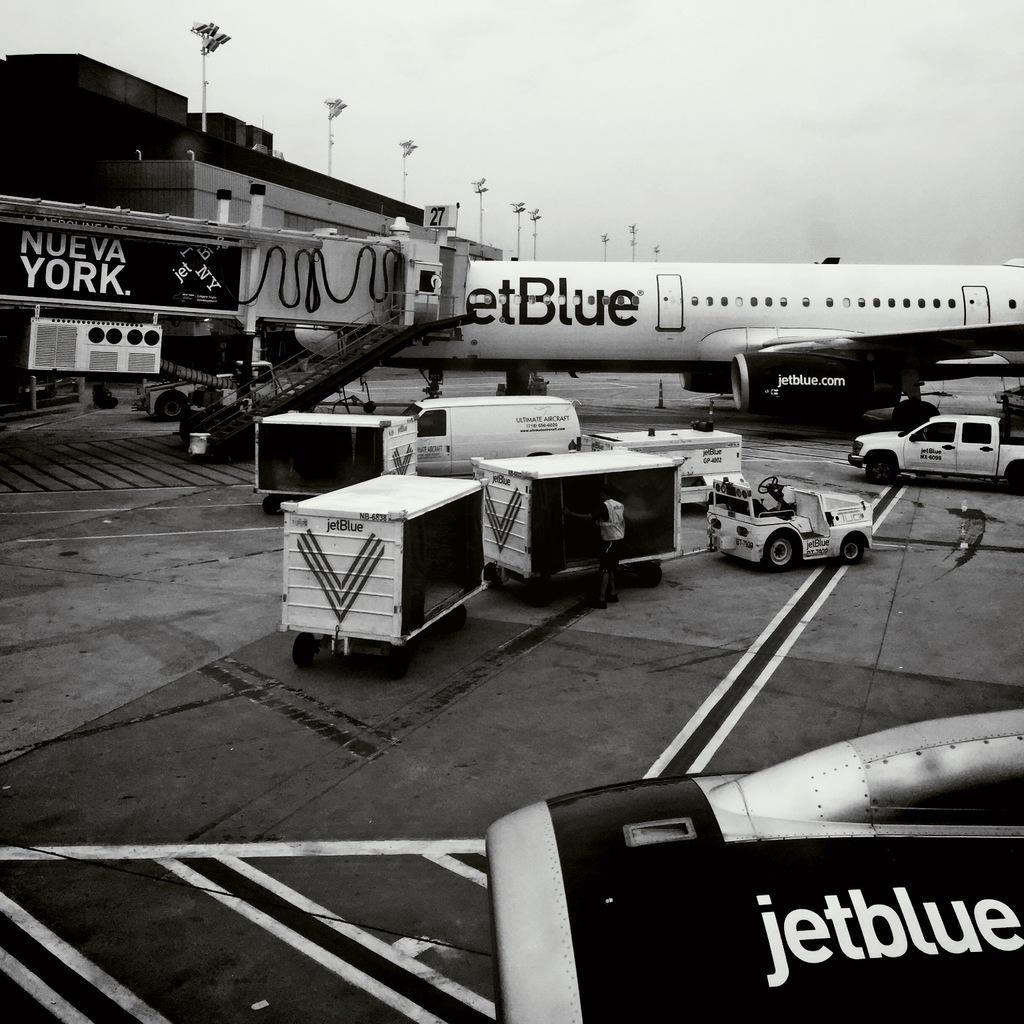Please provide a concise description of this image. In this picture I can see there is a airplane and it has a jet engine, doors, windows, wings and there are few trucks here and there is another jet engine at the bottom of the image and there is a building onto left and the sky is cloudy. This is a black and white picture. 